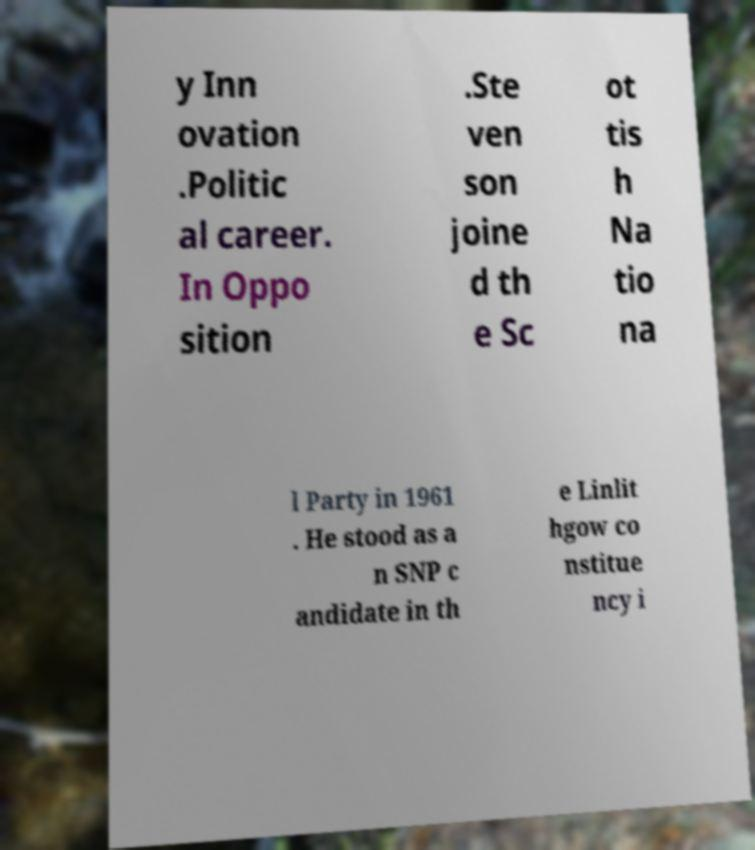Please read and relay the text visible in this image. What does it say? y Inn ovation .Politic al career. In Oppo sition .Ste ven son joine d th e Sc ot tis h Na tio na l Party in 1961 . He stood as a n SNP c andidate in th e Linlit hgow co nstitue ncy i 